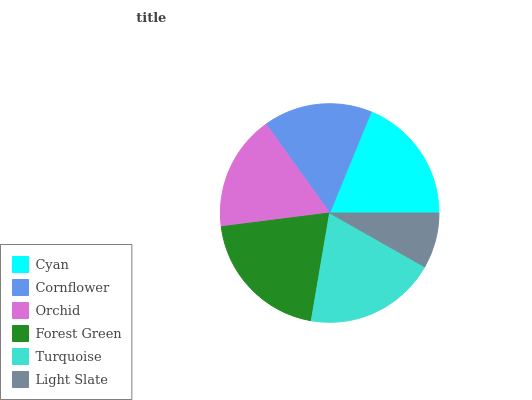Is Light Slate the minimum?
Answer yes or no. Yes. Is Forest Green the maximum?
Answer yes or no. Yes. Is Cornflower the minimum?
Answer yes or no. No. Is Cornflower the maximum?
Answer yes or no. No. Is Cyan greater than Cornflower?
Answer yes or no. Yes. Is Cornflower less than Cyan?
Answer yes or no. Yes. Is Cornflower greater than Cyan?
Answer yes or no. No. Is Cyan less than Cornflower?
Answer yes or no. No. Is Cyan the high median?
Answer yes or no. Yes. Is Orchid the low median?
Answer yes or no. Yes. Is Turquoise the high median?
Answer yes or no. No. Is Cornflower the low median?
Answer yes or no. No. 